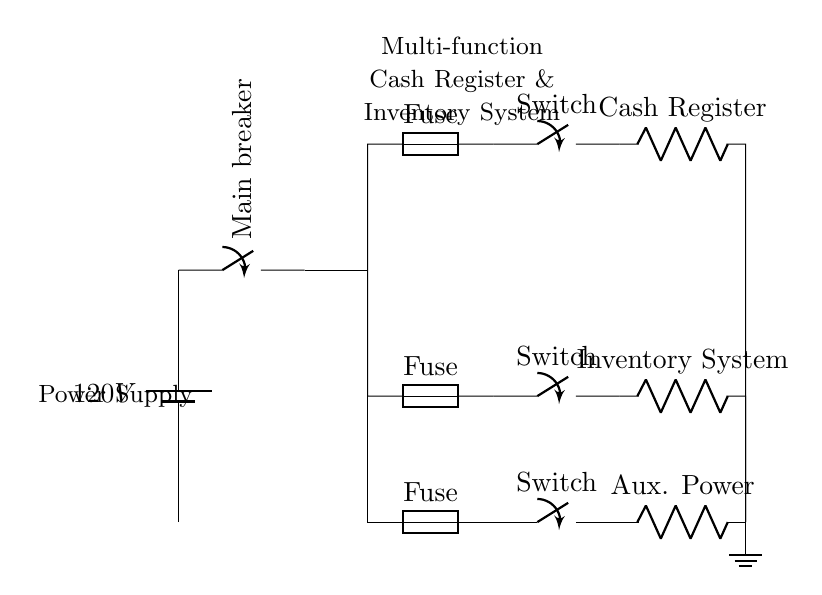What is the voltage of this circuit? The voltage is 120 volts, as indicated by the battery symbol at the top left of the circuit, which specifies the power source voltage.
Answer: 120 volts How many fuses are present in the circuit? There are three fuses shown in the circuit diagram, each connected to different paths for the cash register, inventory system, and auxiliary power.
Answer: Three What component provides power to both the cash register and inventory system? The main power source, which is the battery supplying 120 volts, provides the necessary voltage for both the cash register and the inventory system simultaneously through the power distribution lines.
Answer: Battery Which device is directly connected to the fuse nearest to the battery? The cash register is directly connected to the top fuse in the circuit, as it is the first branch from the main power distribution after the battery and main breaker.
Answer: Cash Register Why are there closing switches in the circuit? The closing switches are important for controlling the power flow to each of the main components: cash register, inventory system, and auxiliary power. They allow for individual activation or deactivation of these components as needed.
Answer: Control power flow What happens if one of the fuses blows? If one of the fuses blows, the specific path of that component (cash register, inventory system, or auxiliary power) would lose power, while the other components could still function provided their fuses are intact.
Answer: Component loses power 